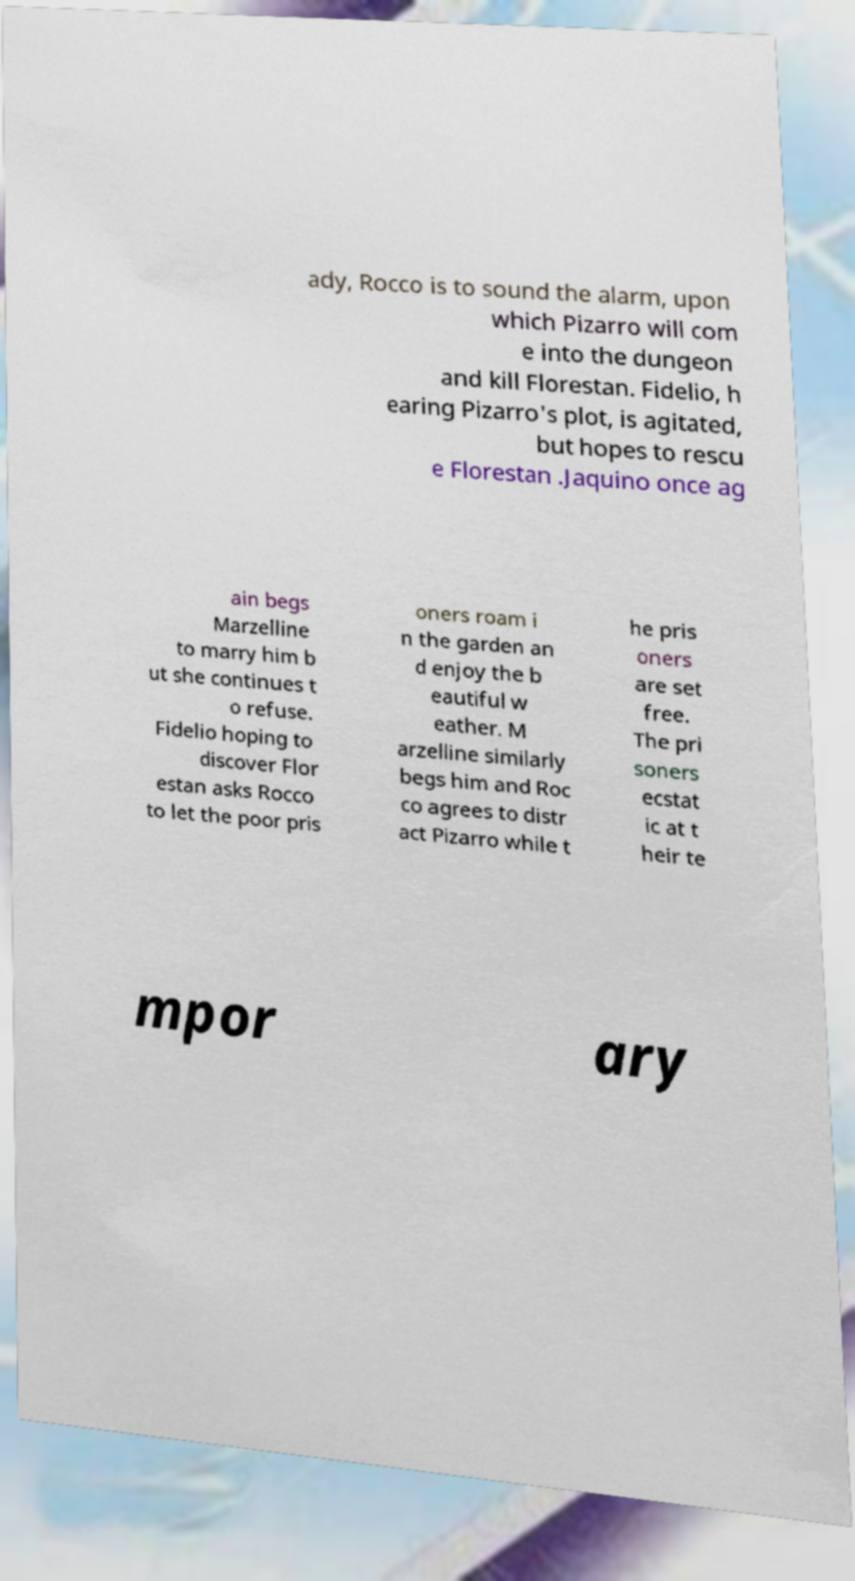What messages or text are displayed in this image? I need them in a readable, typed format. ady, Rocco is to sound the alarm, upon which Pizarro will com e into the dungeon and kill Florestan. Fidelio, h earing Pizarro's plot, is agitated, but hopes to rescu e Florestan .Jaquino once ag ain begs Marzelline to marry him b ut she continues t o refuse. Fidelio hoping to discover Flor estan asks Rocco to let the poor pris oners roam i n the garden an d enjoy the b eautiful w eather. M arzelline similarly begs him and Roc co agrees to distr act Pizarro while t he pris oners are set free. The pri soners ecstat ic at t heir te mpor ary 